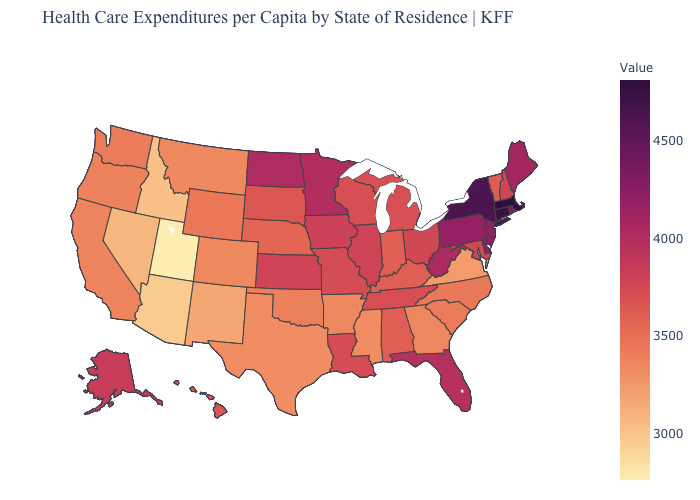Does Massachusetts have the highest value in the USA?
Concise answer only. Yes. Among the states that border New Jersey , which have the highest value?
Short answer required. New York. Does New York have a lower value than Utah?
Answer briefly. No. Among the states that border Minnesota , which have the lowest value?
Quick response, please. South Dakota. Is the legend a continuous bar?
Quick response, please. Yes. Does the map have missing data?
Write a very short answer. No. 